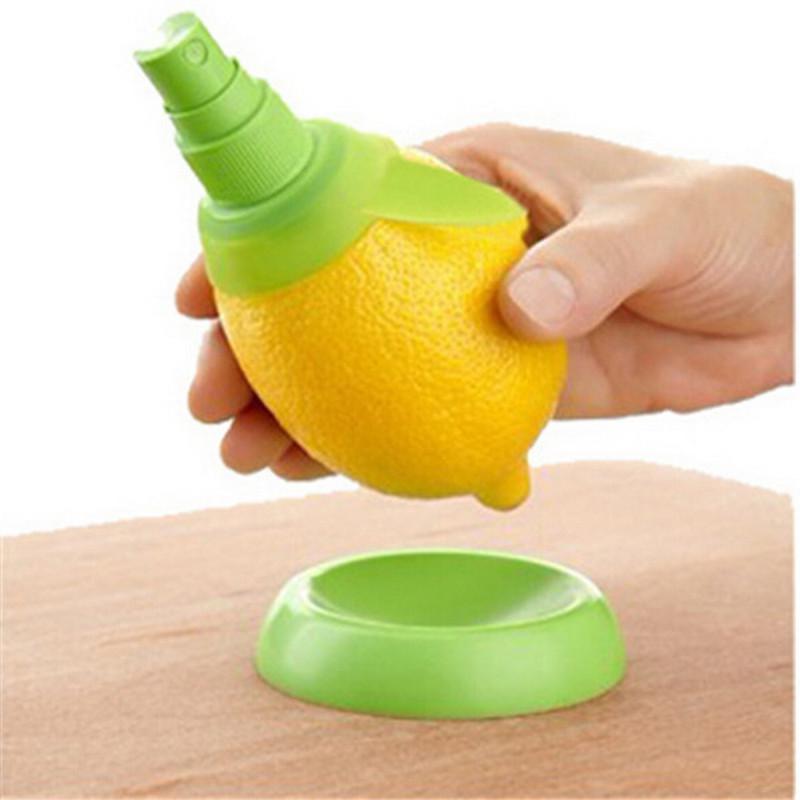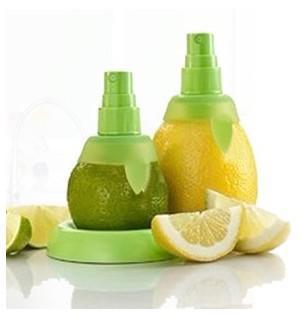The first image is the image on the left, the second image is the image on the right. Evaluate the accuracy of this statement regarding the images: "A person is holding the lemon in the image on the right.". Is it true? Answer yes or no. No. 